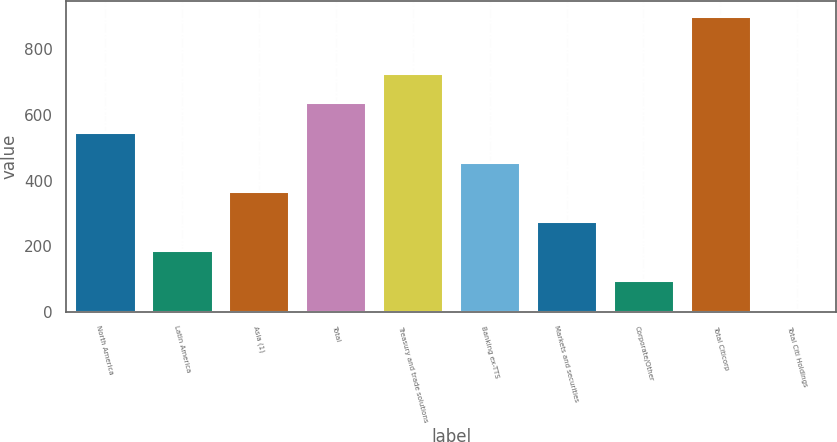Convert chart to OTSL. <chart><loc_0><loc_0><loc_500><loc_500><bar_chart><fcel>North America<fcel>Latin America<fcel>Asia (1)<fcel>Total<fcel>Treasury and trade solutions<fcel>Banking ex-TTS<fcel>Markets and securities<fcel>Corporate/Other<fcel>Total Citicorp<fcel>Total Citi Holdings<nl><fcel>548.12<fcel>187.44<fcel>367.78<fcel>638.29<fcel>728.46<fcel>457.95<fcel>277.61<fcel>97.27<fcel>900.8<fcel>7.1<nl></chart> 